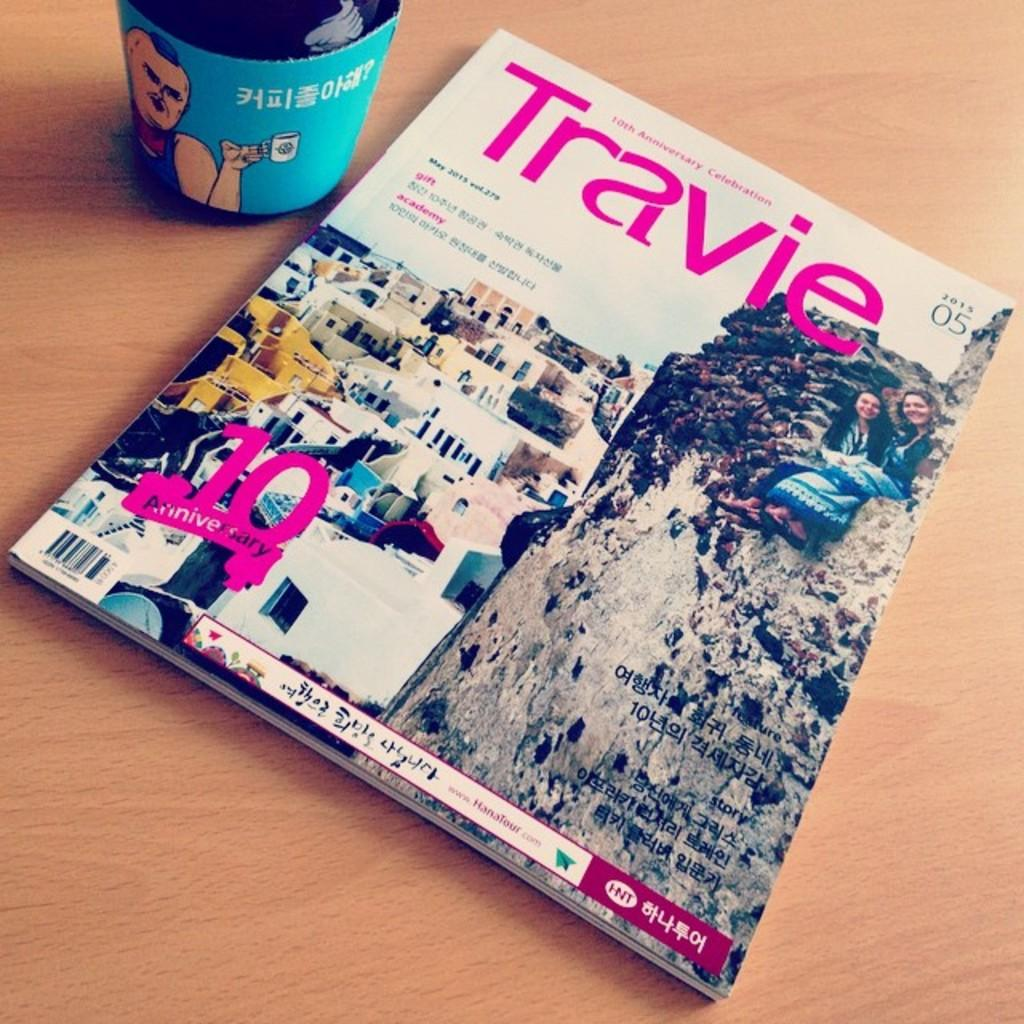Provide a one-sentence caption for the provided image. The cover of Travie magazine recognizes its tenth anniversary. 